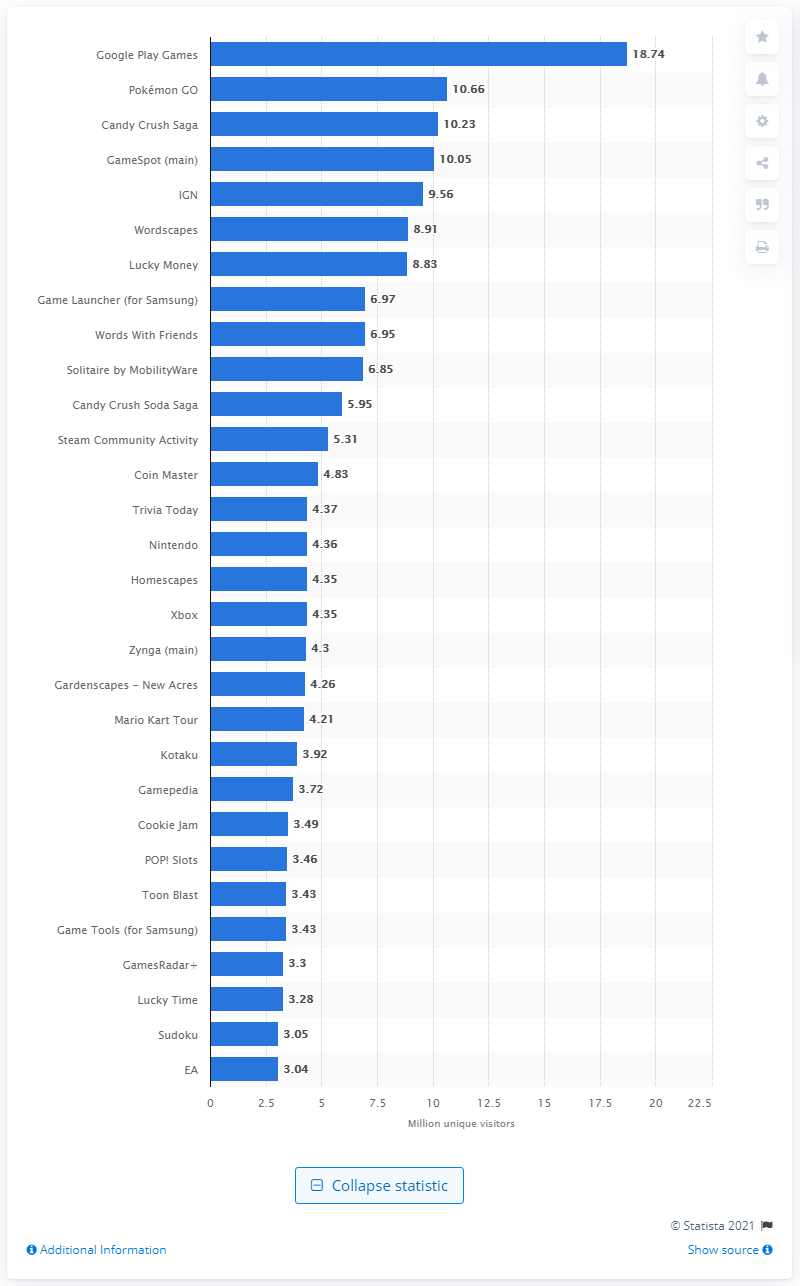Give some essential details in this illustration. In the same month, the number of people who used Pokémon GO was 10.66... As of 2021, Google Play Games had approximately 18.74 million monthly active users. In September 2019, the most popular mobile gaming app in the US was Google Play Games. 